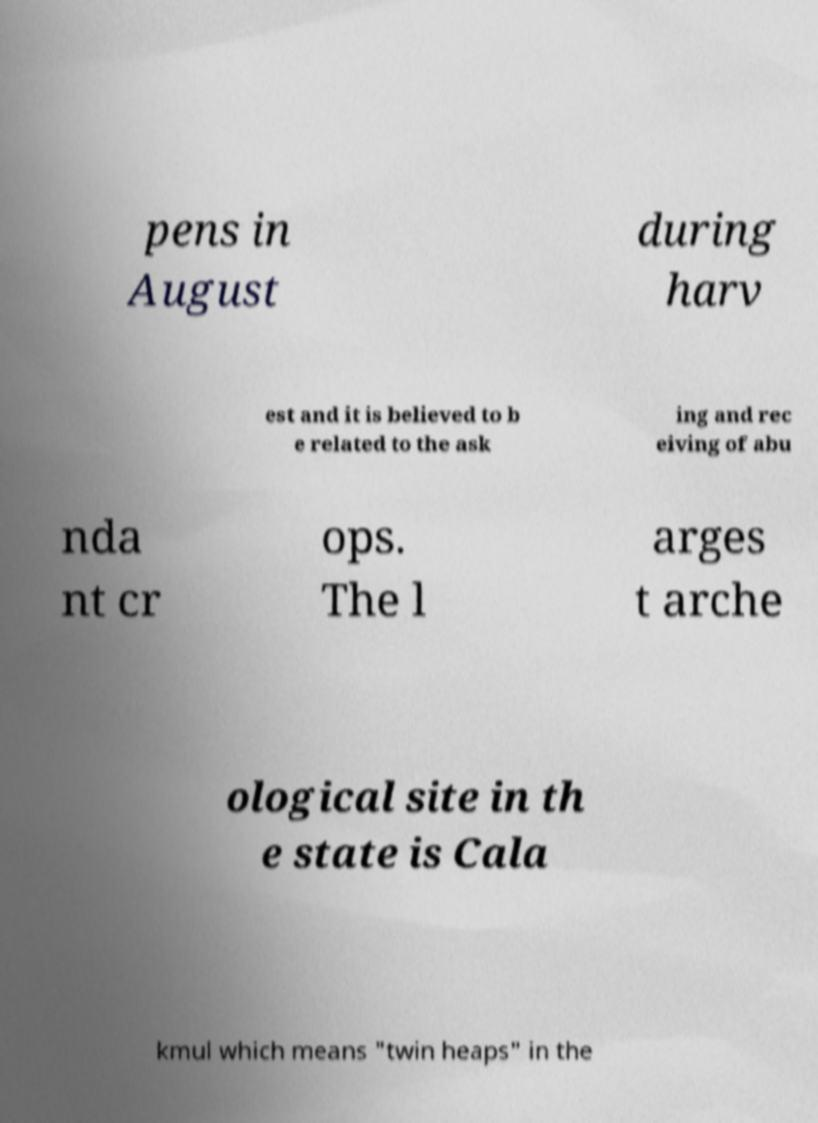I need the written content from this picture converted into text. Can you do that? pens in August during harv est and it is believed to b e related to the ask ing and rec eiving of abu nda nt cr ops. The l arges t arche ological site in th e state is Cala kmul which means "twin heaps" in the 